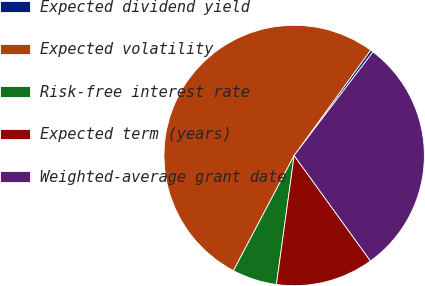Convert chart to OTSL. <chart><loc_0><loc_0><loc_500><loc_500><pie_chart><fcel>Expected dividend yield<fcel>Expected volatility<fcel>Risk-free interest rate<fcel>Expected term (years)<fcel>Weighted-average grant date<nl><fcel>0.36%<fcel>52.27%<fcel>5.55%<fcel>12.14%<fcel>29.68%<nl></chart> 